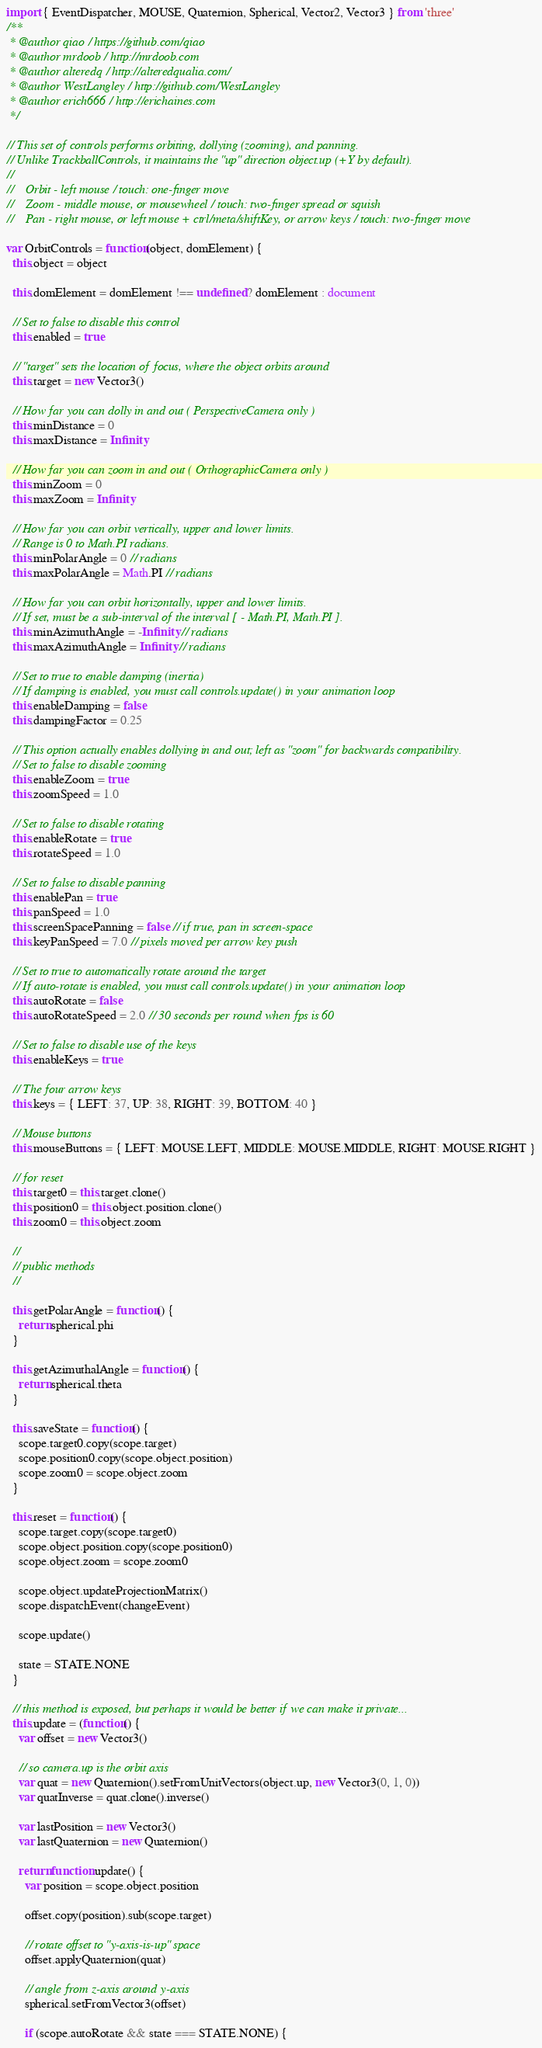<code> <loc_0><loc_0><loc_500><loc_500><_JavaScript_>import { EventDispatcher, MOUSE, Quaternion, Spherical, Vector2, Vector3 } from 'three'
/**
 * @author qiao / https://github.com/qiao
 * @author mrdoob / http://mrdoob.com
 * @author alteredq / http://alteredqualia.com/
 * @author WestLangley / http://github.com/WestLangley
 * @author erich666 / http://erichaines.com
 */

// This set of controls performs orbiting, dollying (zooming), and panning.
// Unlike TrackballControls, it maintains the "up" direction object.up (+Y by default).
//
//    Orbit - left mouse / touch: one-finger move
//    Zoom - middle mouse, or mousewheel / touch: two-finger spread or squish
//    Pan - right mouse, or left mouse + ctrl/meta/shiftKey, or arrow keys / touch: two-finger move

var OrbitControls = function(object, domElement) {
  this.object = object

  this.domElement = domElement !== undefined ? domElement : document

  // Set to false to disable this control
  this.enabled = true

  // "target" sets the location of focus, where the object orbits around
  this.target = new Vector3()

  // How far you can dolly in and out ( PerspectiveCamera only )
  this.minDistance = 0
  this.maxDistance = Infinity

  // How far you can zoom in and out ( OrthographicCamera only )
  this.minZoom = 0
  this.maxZoom = Infinity

  // How far you can orbit vertically, upper and lower limits.
  // Range is 0 to Math.PI radians.
  this.minPolarAngle = 0 // radians
  this.maxPolarAngle = Math.PI // radians

  // How far you can orbit horizontally, upper and lower limits.
  // If set, must be a sub-interval of the interval [ - Math.PI, Math.PI ].
  this.minAzimuthAngle = -Infinity // radians
  this.maxAzimuthAngle = Infinity // radians

  // Set to true to enable damping (inertia)
  // If damping is enabled, you must call controls.update() in your animation loop
  this.enableDamping = false
  this.dampingFactor = 0.25

  // This option actually enables dollying in and out; left as "zoom" for backwards compatibility.
  // Set to false to disable zooming
  this.enableZoom = true
  this.zoomSpeed = 1.0

  // Set to false to disable rotating
  this.enableRotate = true
  this.rotateSpeed = 1.0

  // Set to false to disable panning
  this.enablePan = true
  this.panSpeed = 1.0
  this.screenSpacePanning = false // if true, pan in screen-space
  this.keyPanSpeed = 7.0 // pixels moved per arrow key push

  // Set to true to automatically rotate around the target
  // If auto-rotate is enabled, you must call controls.update() in your animation loop
  this.autoRotate = false
  this.autoRotateSpeed = 2.0 // 30 seconds per round when fps is 60

  // Set to false to disable use of the keys
  this.enableKeys = true

  // The four arrow keys
  this.keys = { LEFT: 37, UP: 38, RIGHT: 39, BOTTOM: 40 }

  // Mouse buttons
  this.mouseButtons = { LEFT: MOUSE.LEFT, MIDDLE: MOUSE.MIDDLE, RIGHT: MOUSE.RIGHT }

  // for reset
  this.target0 = this.target.clone()
  this.position0 = this.object.position.clone()
  this.zoom0 = this.object.zoom

  //
  // public methods
  //

  this.getPolarAngle = function() {
    return spherical.phi
  }

  this.getAzimuthalAngle = function() {
    return spherical.theta
  }

  this.saveState = function() {
    scope.target0.copy(scope.target)
    scope.position0.copy(scope.object.position)
    scope.zoom0 = scope.object.zoom
  }

  this.reset = function() {
    scope.target.copy(scope.target0)
    scope.object.position.copy(scope.position0)
    scope.object.zoom = scope.zoom0

    scope.object.updateProjectionMatrix()
    scope.dispatchEvent(changeEvent)

    scope.update()

    state = STATE.NONE
  }

  // this method is exposed, but perhaps it would be better if we can make it private...
  this.update = (function() {
    var offset = new Vector3()

    // so camera.up is the orbit axis
    var quat = new Quaternion().setFromUnitVectors(object.up, new Vector3(0, 1, 0))
    var quatInverse = quat.clone().inverse()

    var lastPosition = new Vector3()
    var lastQuaternion = new Quaternion()

    return function update() {
      var position = scope.object.position

      offset.copy(position).sub(scope.target)

      // rotate offset to "y-axis-is-up" space
      offset.applyQuaternion(quat)

      // angle from z-axis around y-axis
      spherical.setFromVector3(offset)

      if (scope.autoRotate && state === STATE.NONE) {</code> 